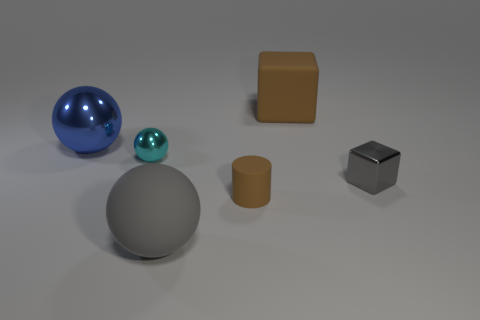There is a gray object that is the same size as the brown matte block; what is it made of?
Provide a succinct answer. Rubber. What number of big gray objects are there?
Provide a short and direct response. 1. There is a tiny thing that is on the right side of the large matte thing that is right of the large gray ball; is there a large block left of it?
Offer a terse response. Yes. The gray object that is the same size as the brown matte block is what shape?
Offer a terse response. Sphere. How many other things are the same color as the large cube?
Ensure brevity in your answer.  1. What material is the tiny cube?
Give a very brief answer. Metal. How many other objects are there of the same material as the brown cube?
Provide a succinct answer. 2. What is the size of the metallic object that is both on the left side of the brown rubber cube and on the right side of the big blue ball?
Keep it short and to the point. Small. There is a gray metal thing in front of the big object to the left of the large gray rubber ball; what shape is it?
Your answer should be very brief. Cube. Is there any other thing that is the same shape as the small brown object?
Give a very brief answer. No. 